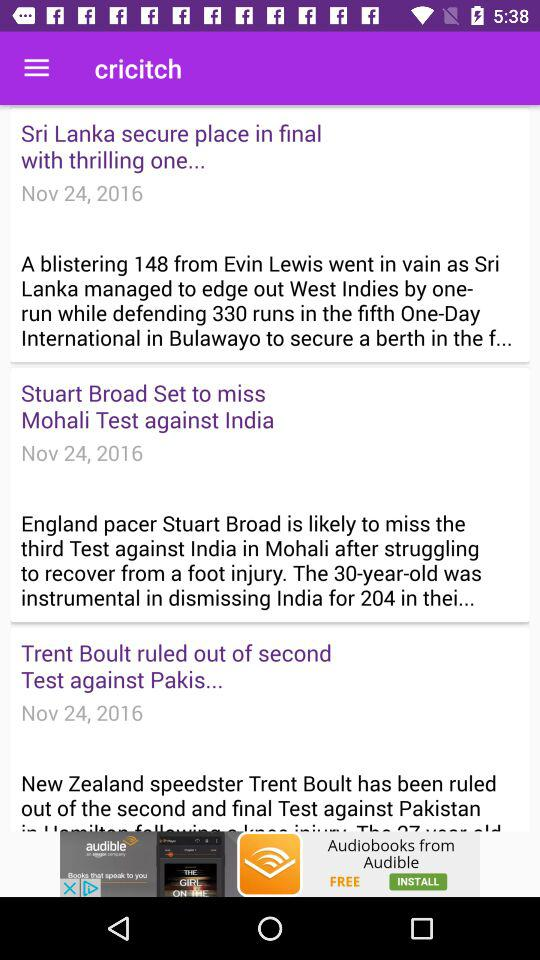By how many runs did "New Zealand" win against "Pakistan"? "New Zealand" won against "Pakistan" by 138 runs. 